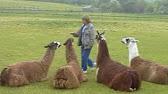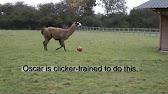The first image is the image on the left, the second image is the image on the right. Assess this claim about the two images: "There is a human interacting with the livestock.". Correct or not? Answer yes or no. Yes. The first image is the image on the left, the second image is the image on the right. Considering the images on both sides, is "There is one human near at least one llama one oft he images." valid? Answer yes or no. Yes. 